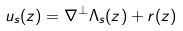<formula> <loc_0><loc_0><loc_500><loc_500>u _ { s } ( z ) = \nabla ^ { \perp } \Lambda _ { s } ( z ) + r ( z )</formula> 